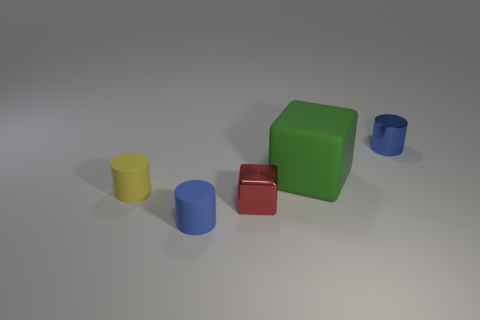The shiny cylinder is what color? blue 